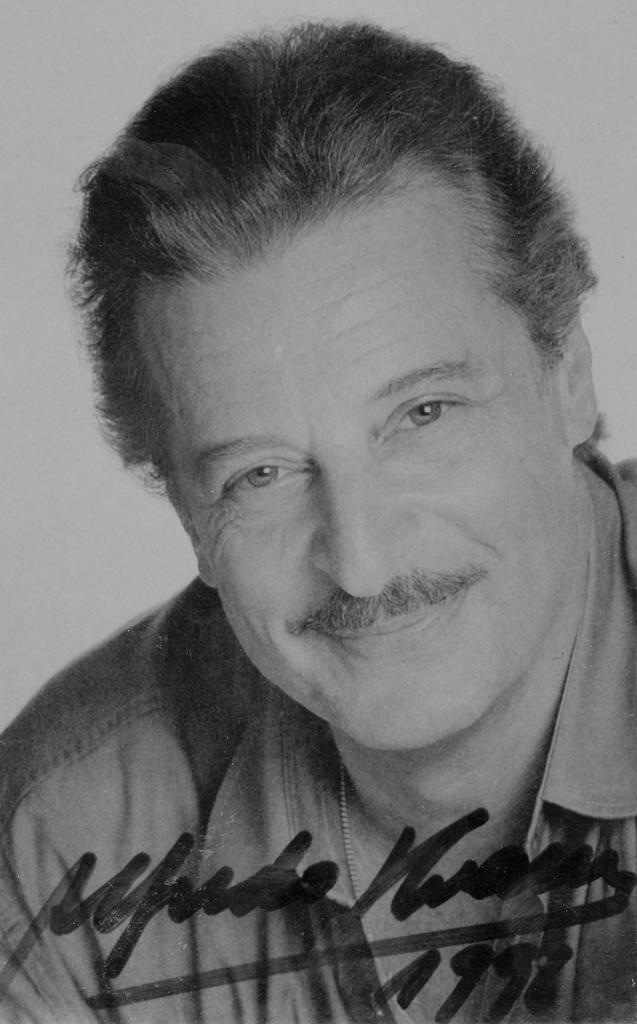In one or two sentences, can you explain what this image depicts? This is a black and white image. I can see the man smiling. She wore a shirt. This looks like an autograph in the image. 